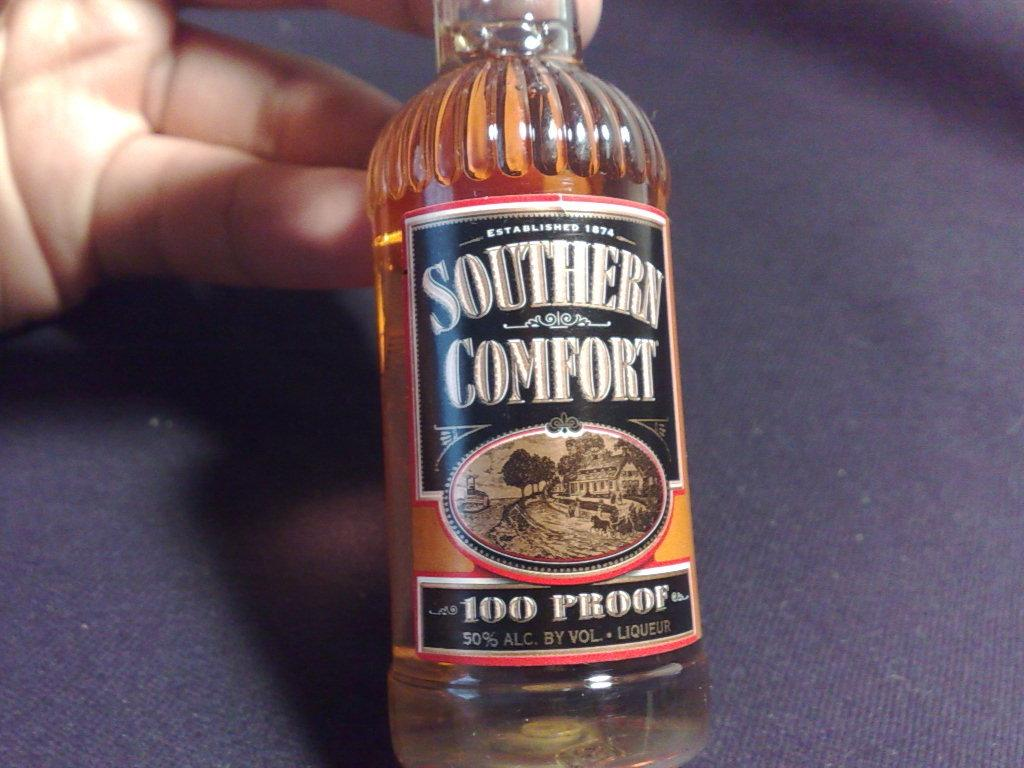<image>
Present a compact description of the photo's key features. A small bottle of Southern Comfort is propped up by someone's hand over a blue cloth. 